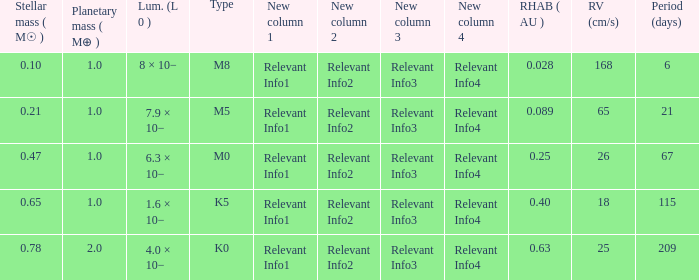What is the smallest period (days) to have a planetary mass of 1, a stellar mass greater than 0.21 and of the type M0? 67.0. 